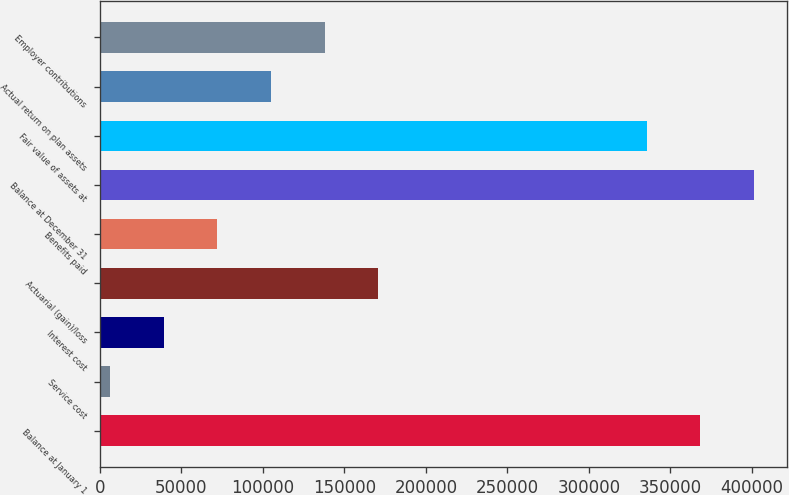Convert chart. <chart><loc_0><loc_0><loc_500><loc_500><bar_chart><fcel>Balance at January 1<fcel>Service cost<fcel>Interest cost<fcel>Actuarial (gain)/loss<fcel>Benefits paid<fcel>Balance at December 31<fcel>Fair value of assets at<fcel>Actual return on plan assets<fcel>Employer contributions<nl><fcel>368293<fcel>6263<fcel>39174.8<fcel>170822<fcel>72086.6<fcel>401205<fcel>335381<fcel>104998<fcel>137910<nl></chart> 